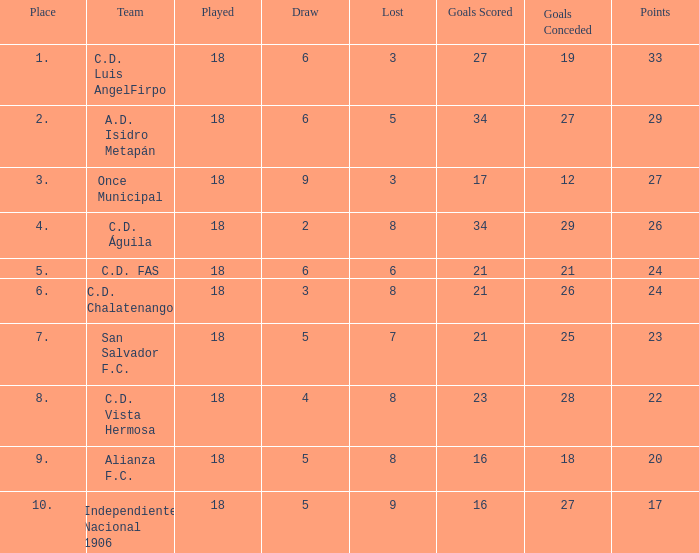What's the place that Once Municipal has a lost greater than 3? None. 